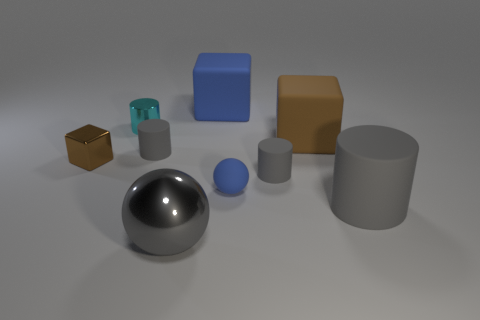What materials do these objects seem to be made of? The objects appear to be made of different materials. The large shiny sphere looks like polished metal, the transparent teal block seems to be glass or acrylic, and the remaining objects appear to be made of matte surfaces, possibly plastic or painted wood. Are there any reflections on the objects, and if so, what do they reveal about the surroundings? Yes, there are reflections visible, especially on the metallic sphere which mirrors the gray environment and the lighting setup. These reflections suggest that the objects are situated in a nondescript space with a strong light source from above, possibly in a studio setting. 